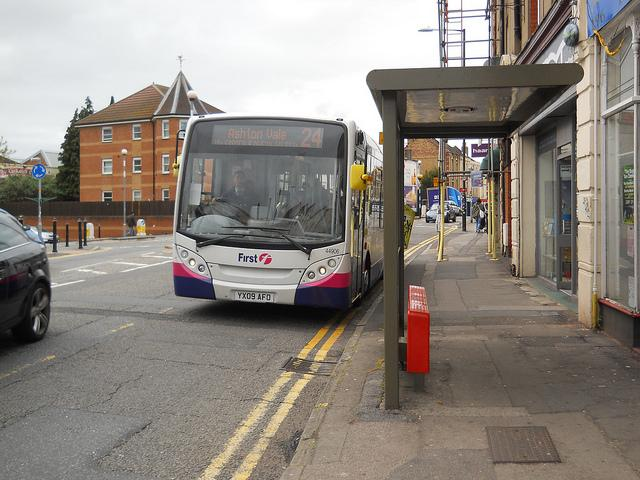Where is this bus headed next? Please explain your reasoning. ashton vale. Ashton vale is displayed on the digital screen. 